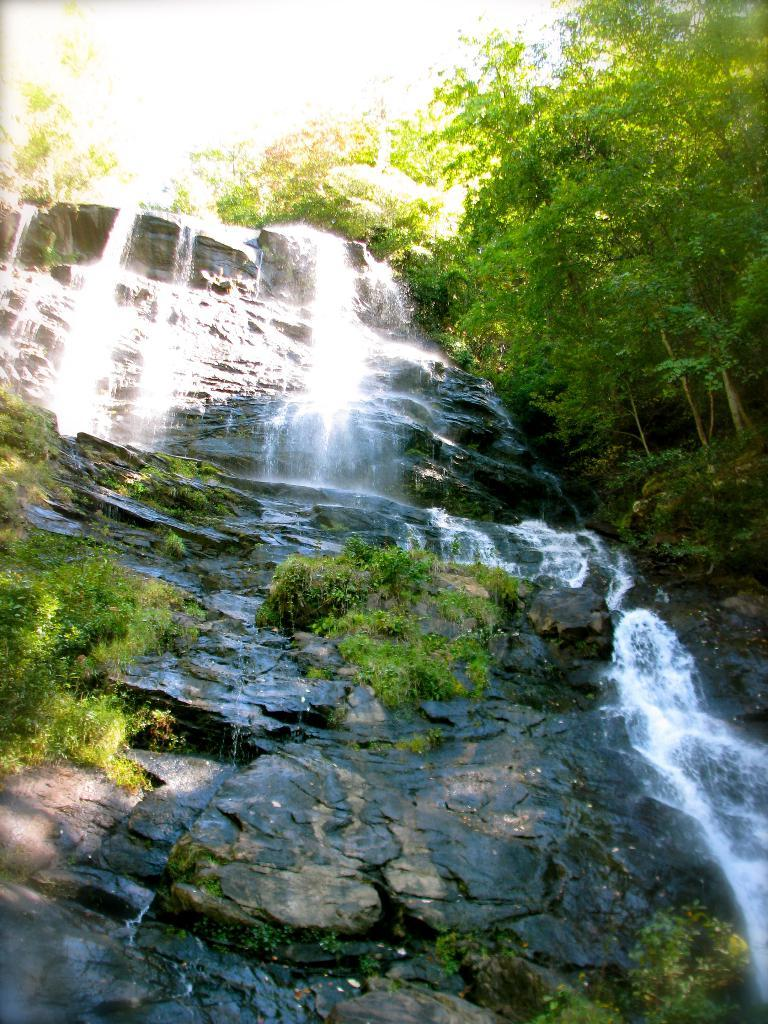What is the main feature in the center of the image? There is a waterfall in the center of the image. What type of natural elements can be seen in the image? There are plants, rocks, and trees in the image. Reasoning: Let' Let's think step by step in order to produce the conversation. We start by identifying the main subject of the image, which is the waterfall. Then, we describe the natural elements present in the image, such as plants, rocks, and trees. Each question is designed to elicit a specific detail about the image that is known from the provided facts. Absurd Question/Answer: How many bikes are parked near the waterfall in the image? There are no bikes present in the image; it features a waterfall, plants, rocks, and trees. 